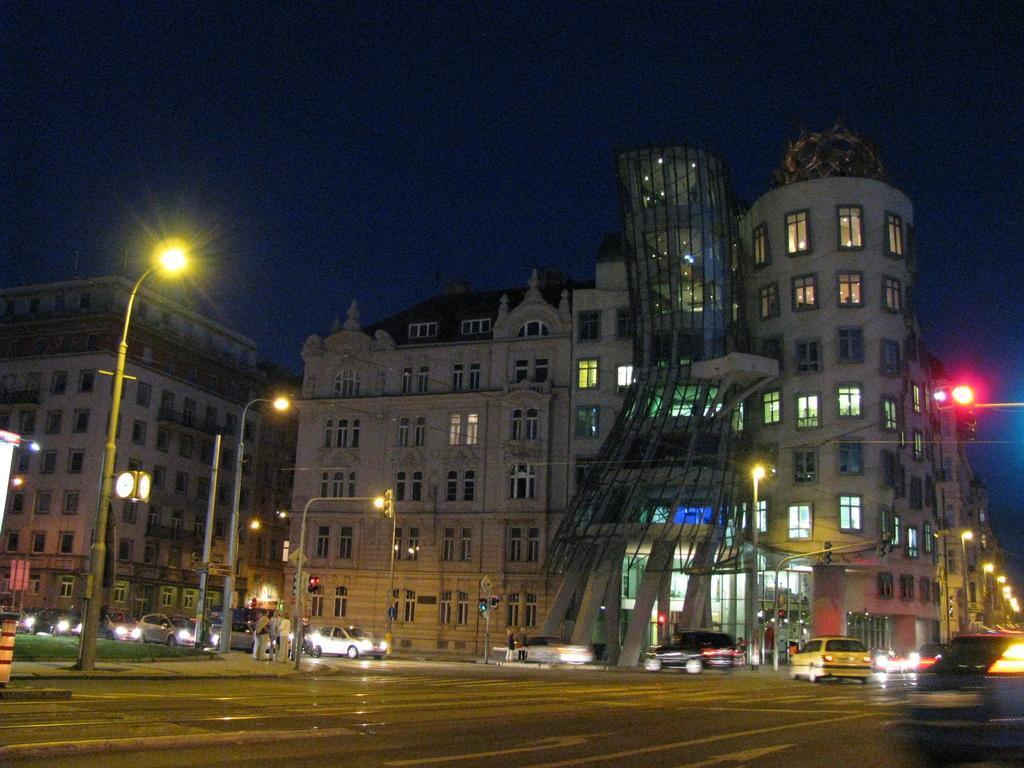Describe this image in one or two sentences. In the foreground I can see fleets of cars, group of people, street lights and boards on the road. In the background I can see buildings, windows and the sky. This image is taken during night. 